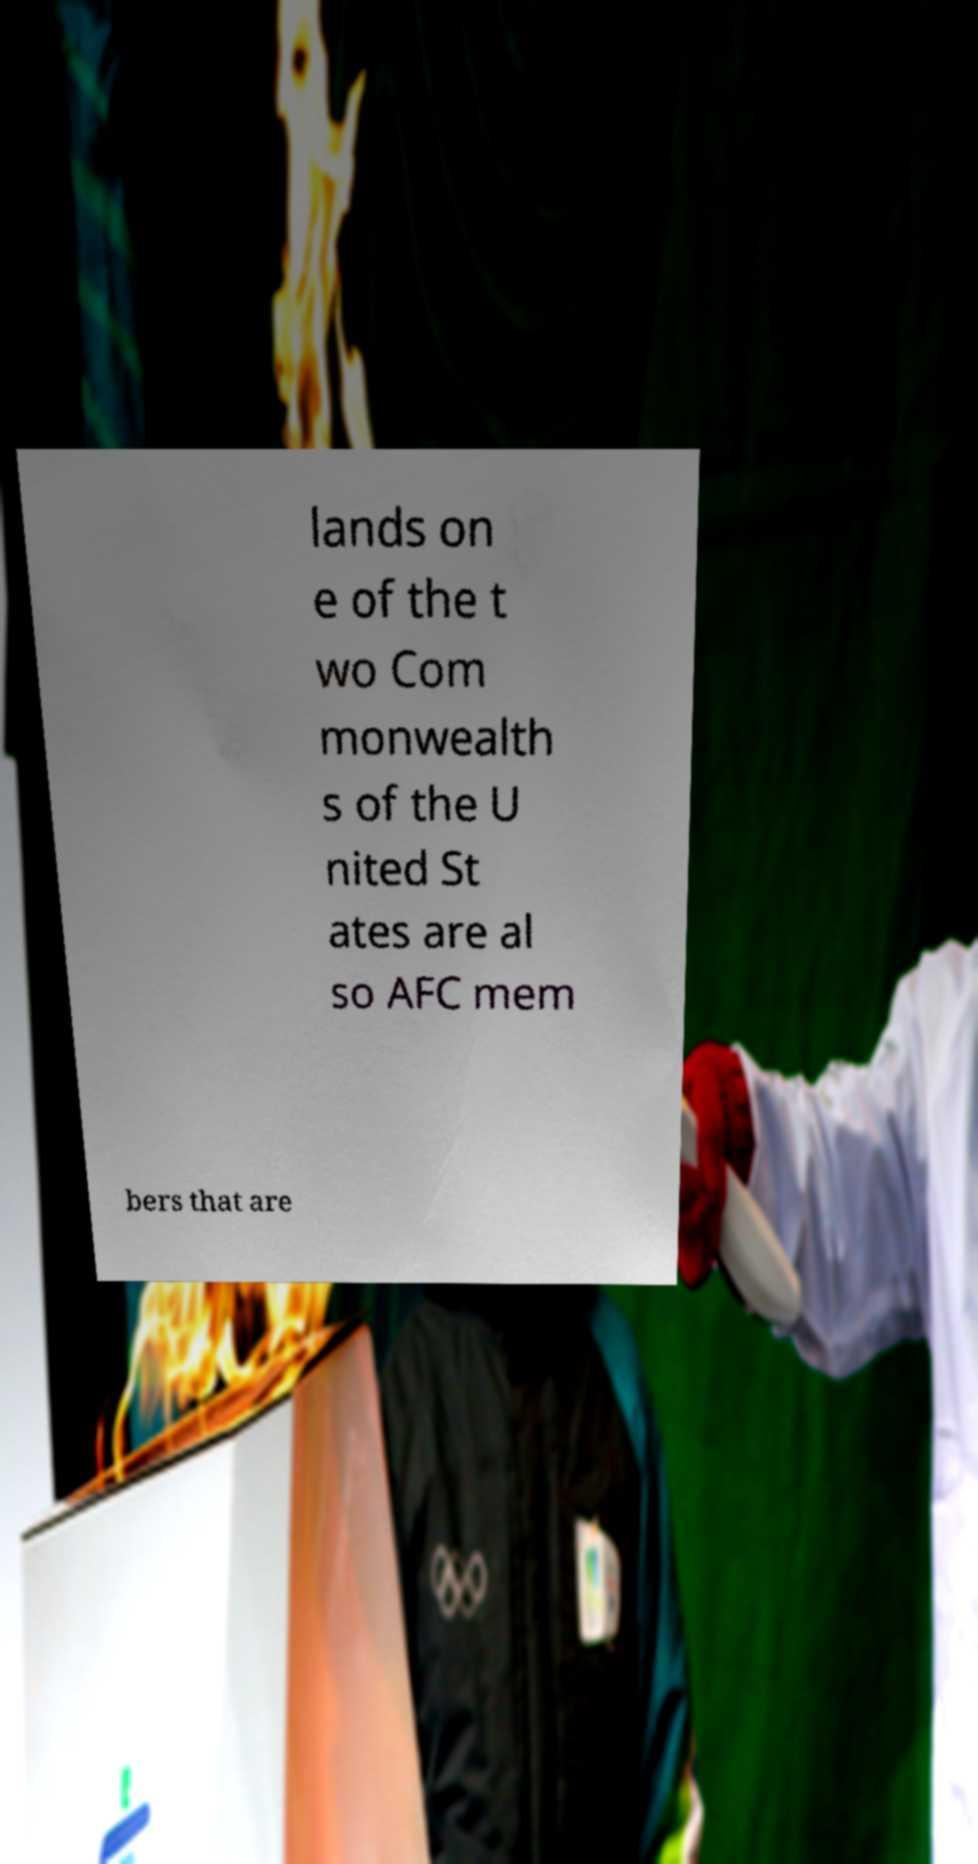Can you read and provide the text displayed in the image?This photo seems to have some interesting text. Can you extract and type it out for me? lands on e of the t wo Com monwealth s of the U nited St ates are al so AFC mem bers that are 